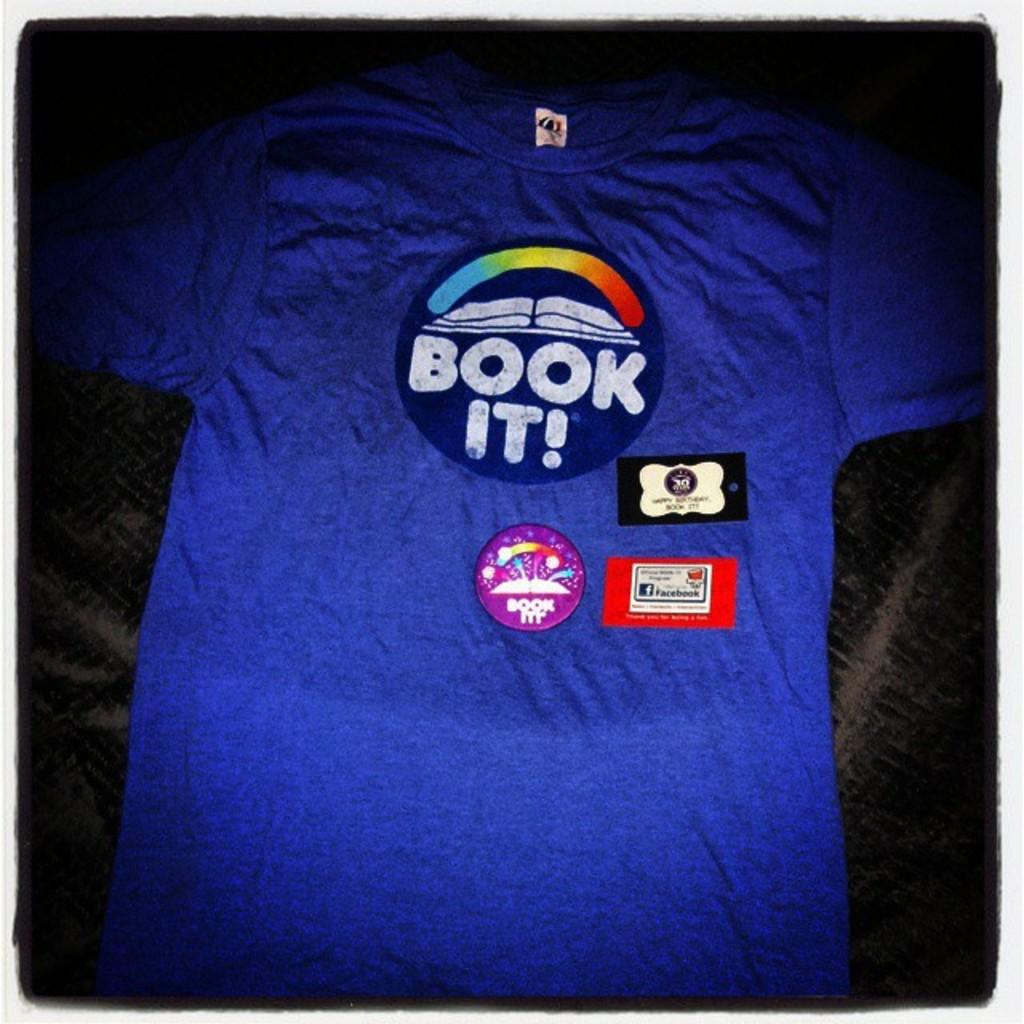Provide a one-sentence caption for the provided image. A blue tee shirt with the slogan book it on a circle. 